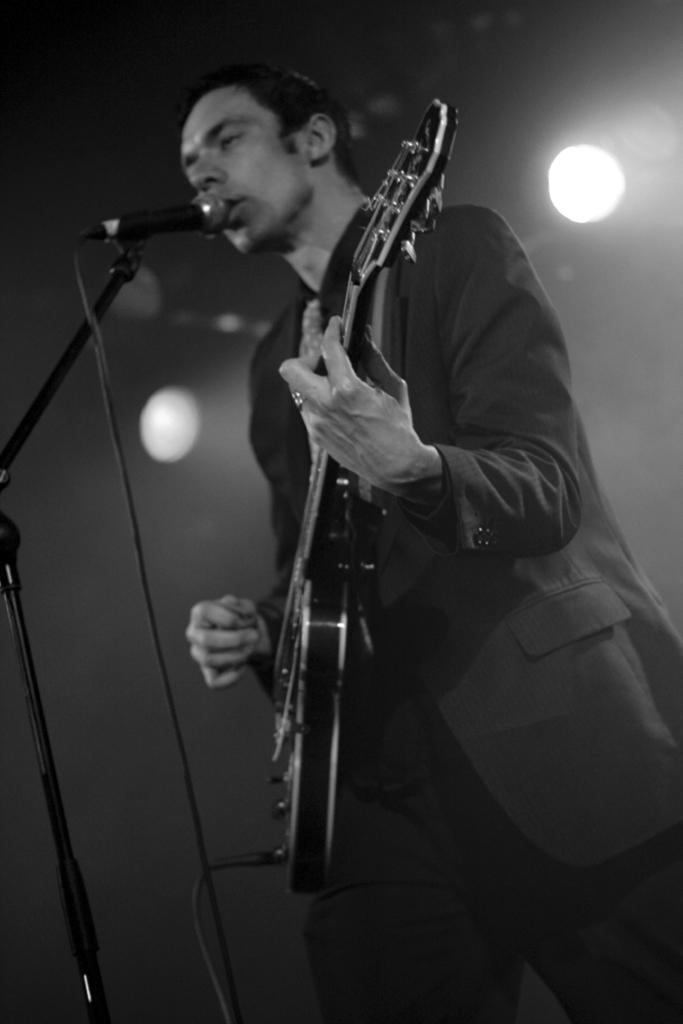Can you describe this image briefly? In this image i can see a man is playing a guitar in front of a microphone. The man is wearing a coat. 